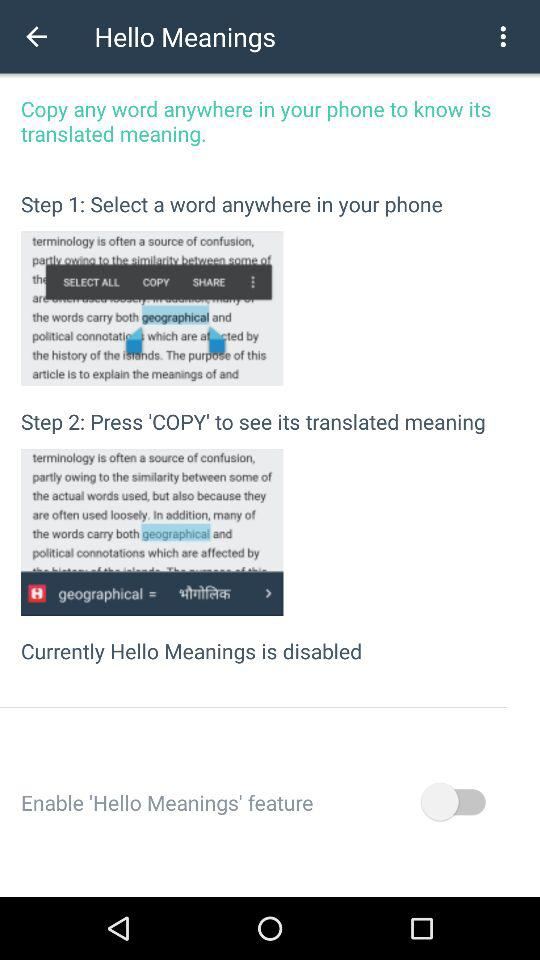What is "Step 1"? The "Step 1" is "Select a word anywhere in your phone". 